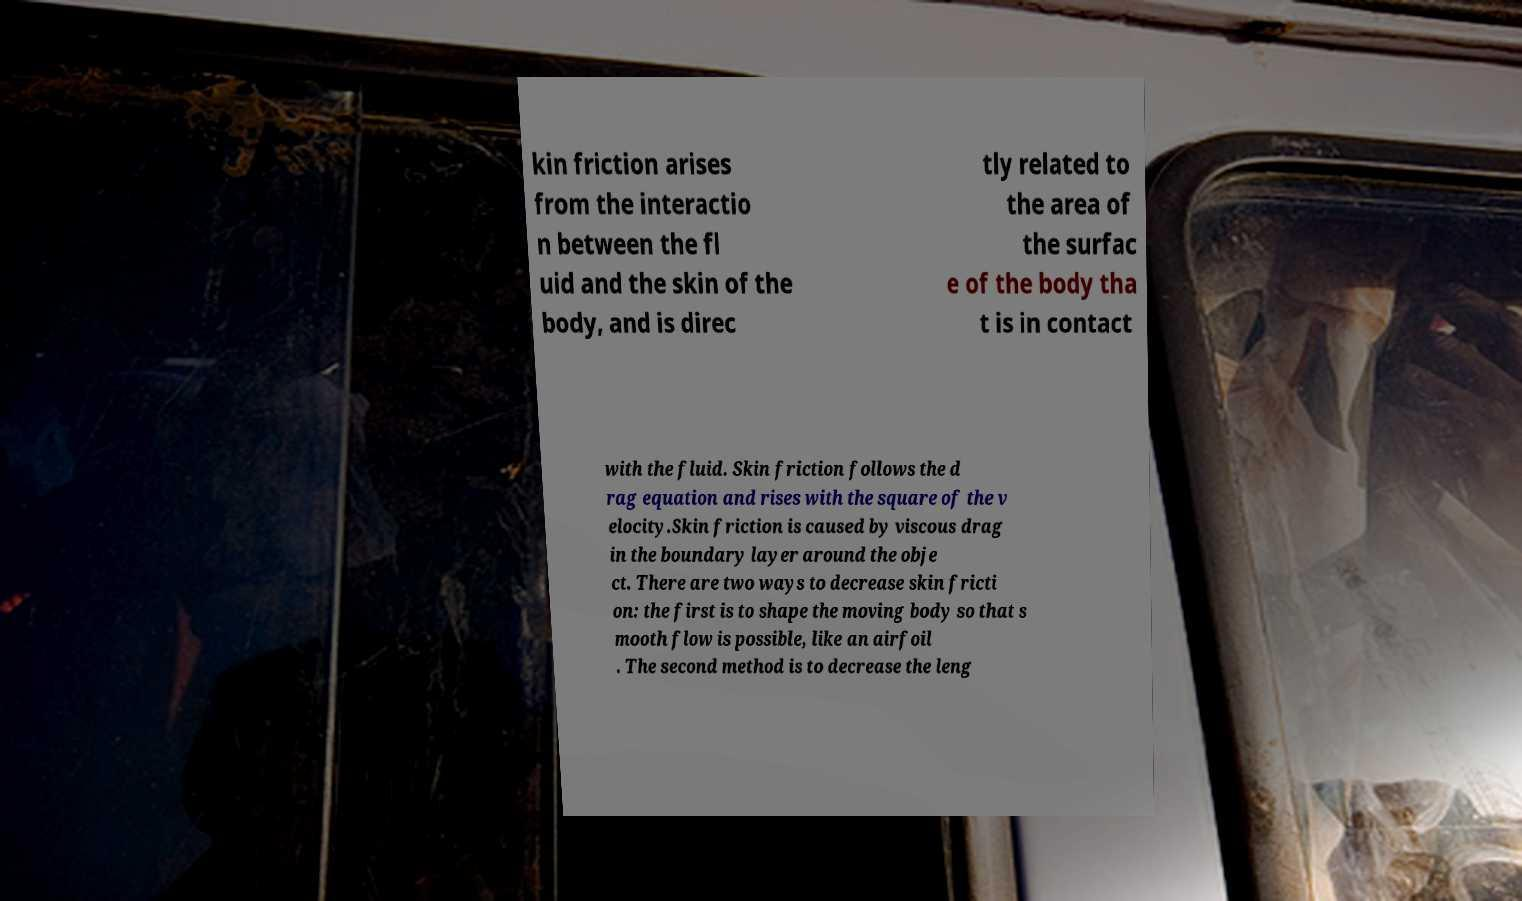Please identify and transcribe the text found in this image. kin friction arises from the interactio n between the fl uid and the skin of the body, and is direc tly related to the area of the surfac e of the body tha t is in contact with the fluid. Skin friction follows the d rag equation and rises with the square of the v elocity.Skin friction is caused by viscous drag in the boundary layer around the obje ct. There are two ways to decrease skin fricti on: the first is to shape the moving body so that s mooth flow is possible, like an airfoil . The second method is to decrease the leng 